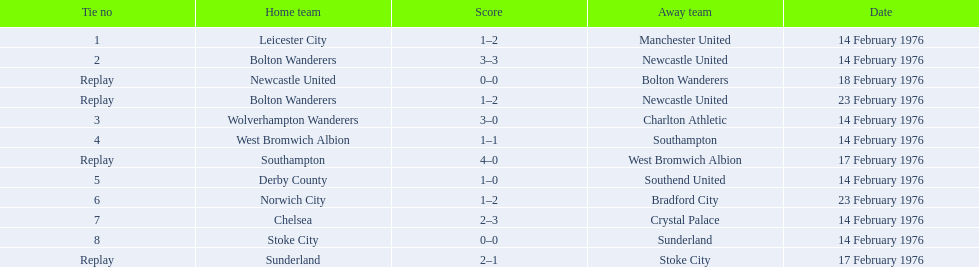Who were all the teams that played? Leicester City, Manchester United, Bolton Wanderers, Newcastle United, Newcastle United, Bolton Wanderers, Bolton Wanderers, Newcastle United, Wolverhampton Wanderers, Charlton Athletic, West Bromwich Albion, Southampton, Southampton, West Bromwich Albion, Derby County, Southend United, Norwich City, Bradford City, Chelsea, Crystal Palace, Stoke City, Sunderland, Sunderland, Stoke City. Which of these teams won? Manchester United, Newcastle United, Wolverhampton Wanderers, Southampton, Derby County, Bradford City, Crystal Palace, Sunderland. What was manchester united's winning score? 1–2. What was the wolverhampton wonders winning score? 3–0. Which of these two teams had the better winning score? Wolverhampton Wanderers. 